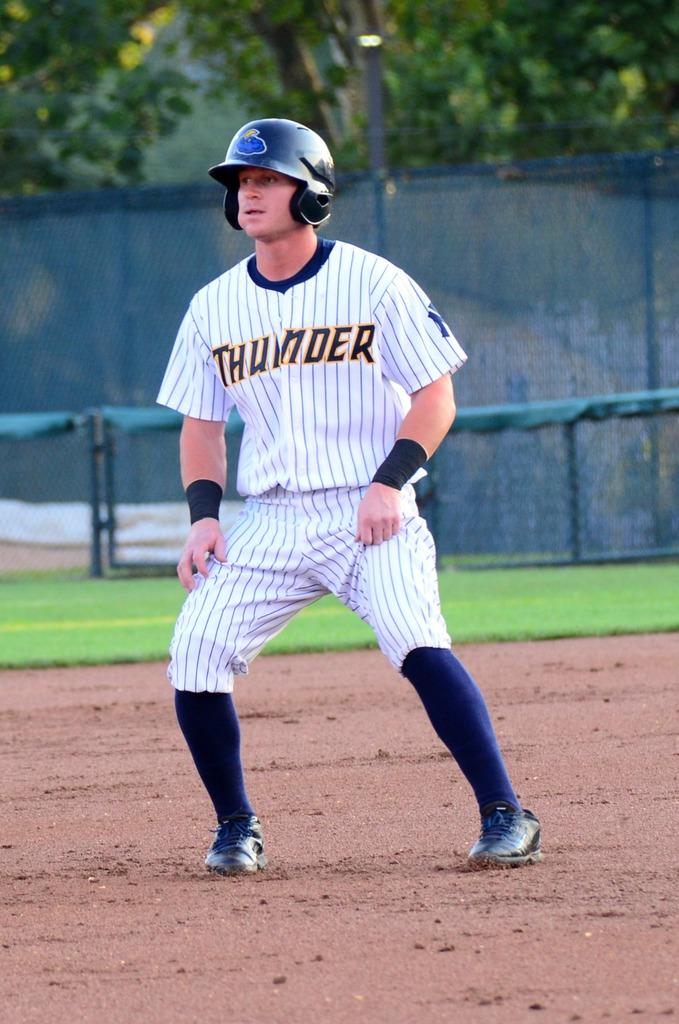<image>
Provide a brief description of the given image. Baseball player with a thunder jersey and helmet on field 